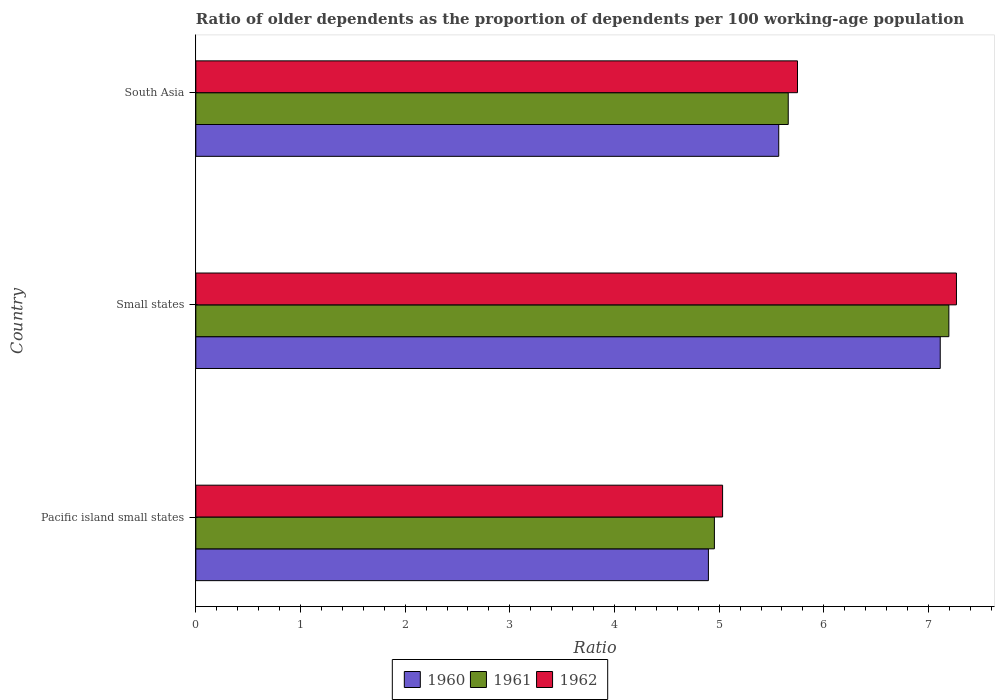Are the number of bars per tick equal to the number of legend labels?
Your answer should be very brief. Yes. Are the number of bars on each tick of the Y-axis equal?
Provide a succinct answer. Yes. How many bars are there on the 3rd tick from the top?
Offer a terse response. 3. How many bars are there on the 3rd tick from the bottom?
Your answer should be very brief. 3. What is the label of the 2nd group of bars from the top?
Offer a very short reply. Small states. In how many cases, is the number of bars for a given country not equal to the number of legend labels?
Offer a terse response. 0. What is the age dependency ratio(old) in 1960 in Pacific island small states?
Offer a terse response. 4.9. Across all countries, what is the maximum age dependency ratio(old) in 1961?
Keep it short and to the point. 7.19. Across all countries, what is the minimum age dependency ratio(old) in 1962?
Your answer should be compact. 5.03. In which country was the age dependency ratio(old) in 1960 maximum?
Keep it short and to the point. Small states. In which country was the age dependency ratio(old) in 1960 minimum?
Give a very brief answer. Pacific island small states. What is the total age dependency ratio(old) in 1960 in the graph?
Offer a very short reply. 17.58. What is the difference between the age dependency ratio(old) in 1962 in Pacific island small states and that in Small states?
Provide a succinct answer. -2.23. What is the difference between the age dependency ratio(old) in 1960 in Pacific island small states and the age dependency ratio(old) in 1962 in Small states?
Offer a terse response. -2.37. What is the average age dependency ratio(old) in 1962 per country?
Provide a succinct answer. 6.02. What is the difference between the age dependency ratio(old) in 1962 and age dependency ratio(old) in 1960 in Pacific island small states?
Your answer should be very brief. 0.14. What is the ratio of the age dependency ratio(old) in 1961 in Pacific island small states to that in South Asia?
Your response must be concise. 0.88. Is the difference between the age dependency ratio(old) in 1962 in Small states and South Asia greater than the difference between the age dependency ratio(old) in 1960 in Small states and South Asia?
Make the answer very short. No. What is the difference between the highest and the second highest age dependency ratio(old) in 1960?
Your answer should be compact. 1.54. What is the difference between the highest and the lowest age dependency ratio(old) in 1960?
Make the answer very short. 2.21. In how many countries, is the age dependency ratio(old) in 1960 greater than the average age dependency ratio(old) in 1960 taken over all countries?
Provide a succinct answer. 1. Is the sum of the age dependency ratio(old) in 1961 in Pacific island small states and Small states greater than the maximum age dependency ratio(old) in 1960 across all countries?
Your answer should be compact. Yes. What does the 2nd bar from the top in Pacific island small states represents?
Your answer should be compact. 1961. What does the 3rd bar from the bottom in Pacific island small states represents?
Your response must be concise. 1962. Is it the case that in every country, the sum of the age dependency ratio(old) in 1962 and age dependency ratio(old) in 1961 is greater than the age dependency ratio(old) in 1960?
Ensure brevity in your answer.  Yes. How many bars are there?
Provide a succinct answer. 9. What is the difference between two consecutive major ticks on the X-axis?
Offer a very short reply. 1. Does the graph contain any zero values?
Keep it short and to the point. No. Does the graph contain grids?
Make the answer very short. No. Where does the legend appear in the graph?
Provide a short and direct response. Bottom center. How many legend labels are there?
Ensure brevity in your answer.  3. What is the title of the graph?
Your response must be concise. Ratio of older dependents as the proportion of dependents per 100 working-age population. What is the label or title of the X-axis?
Your answer should be very brief. Ratio. What is the label or title of the Y-axis?
Provide a short and direct response. Country. What is the Ratio of 1960 in Pacific island small states?
Offer a terse response. 4.9. What is the Ratio in 1961 in Pacific island small states?
Your answer should be compact. 4.95. What is the Ratio in 1962 in Pacific island small states?
Make the answer very short. 5.03. What is the Ratio of 1960 in Small states?
Make the answer very short. 7.11. What is the Ratio in 1961 in Small states?
Provide a short and direct response. 7.19. What is the Ratio of 1962 in Small states?
Your answer should be very brief. 7.27. What is the Ratio of 1960 in South Asia?
Offer a terse response. 5.57. What is the Ratio of 1961 in South Asia?
Keep it short and to the point. 5.66. What is the Ratio of 1962 in South Asia?
Ensure brevity in your answer.  5.75. Across all countries, what is the maximum Ratio in 1960?
Ensure brevity in your answer.  7.11. Across all countries, what is the maximum Ratio of 1961?
Your response must be concise. 7.19. Across all countries, what is the maximum Ratio in 1962?
Keep it short and to the point. 7.27. Across all countries, what is the minimum Ratio of 1960?
Offer a terse response. 4.9. Across all countries, what is the minimum Ratio of 1961?
Your answer should be very brief. 4.95. Across all countries, what is the minimum Ratio of 1962?
Make the answer very short. 5.03. What is the total Ratio in 1960 in the graph?
Give a very brief answer. 17.58. What is the total Ratio in 1961 in the graph?
Your response must be concise. 17.81. What is the total Ratio of 1962 in the graph?
Make the answer very short. 18.05. What is the difference between the Ratio in 1960 in Pacific island small states and that in Small states?
Your answer should be compact. -2.21. What is the difference between the Ratio of 1961 in Pacific island small states and that in Small states?
Offer a terse response. -2.24. What is the difference between the Ratio in 1962 in Pacific island small states and that in Small states?
Offer a terse response. -2.23. What is the difference between the Ratio in 1960 in Pacific island small states and that in South Asia?
Provide a succinct answer. -0.67. What is the difference between the Ratio in 1961 in Pacific island small states and that in South Asia?
Offer a very short reply. -0.71. What is the difference between the Ratio in 1962 in Pacific island small states and that in South Asia?
Provide a short and direct response. -0.72. What is the difference between the Ratio in 1960 in Small states and that in South Asia?
Your response must be concise. 1.54. What is the difference between the Ratio of 1961 in Small states and that in South Asia?
Give a very brief answer. 1.53. What is the difference between the Ratio in 1962 in Small states and that in South Asia?
Offer a very short reply. 1.52. What is the difference between the Ratio of 1960 in Pacific island small states and the Ratio of 1961 in Small states?
Your answer should be compact. -2.3. What is the difference between the Ratio in 1960 in Pacific island small states and the Ratio in 1962 in Small states?
Give a very brief answer. -2.37. What is the difference between the Ratio in 1961 in Pacific island small states and the Ratio in 1962 in Small states?
Offer a very short reply. -2.31. What is the difference between the Ratio in 1960 in Pacific island small states and the Ratio in 1961 in South Asia?
Provide a short and direct response. -0.76. What is the difference between the Ratio in 1960 in Pacific island small states and the Ratio in 1962 in South Asia?
Offer a terse response. -0.85. What is the difference between the Ratio of 1961 in Pacific island small states and the Ratio of 1962 in South Asia?
Ensure brevity in your answer.  -0.79. What is the difference between the Ratio of 1960 in Small states and the Ratio of 1961 in South Asia?
Provide a succinct answer. 1.45. What is the difference between the Ratio in 1960 in Small states and the Ratio in 1962 in South Asia?
Provide a succinct answer. 1.36. What is the difference between the Ratio in 1961 in Small states and the Ratio in 1962 in South Asia?
Make the answer very short. 1.45. What is the average Ratio in 1960 per country?
Offer a terse response. 5.86. What is the average Ratio of 1961 per country?
Provide a succinct answer. 5.94. What is the average Ratio in 1962 per country?
Provide a short and direct response. 6.02. What is the difference between the Ratio in 1960 and Ratio in 1961 in Pacific island small states?
Give a very brief answer. -0.06. What is the difference between the Ratio of 1960 and Ratio of 1962 in Pacific island small states?
Provide a succinct answer. -0.14. What is the difference between the Ratio of 1961 and Ratio of 1962 in Pacific island small states?
Ensure brevity in your answer.  -0.08. What is the difference between the Ratio of 1960 and Ratio of 1961 in Small states?
Offer a very short reply. -0.08. What is the difference between the Ratio of 1960 and Ratio of 1962 in Small states?
Give a very brief answer. -0.15. What is the difference between the Ratio in 1961 and Ratio in 1962 in Small states?
Offer a terse response. -0.07. What is the difference between the Ratio in 1960 and Ratio in 1961 in South Asia?
Your answer should be compact. -0.09. What is the difference between the Ratio in 1960 and Ratio in 1962 in South Asia?
Keep it short and to the point. -0.18. What is the difference between the Ratio in 1961 and Ratio in 1962 in South Asia?
Your answer should be compact. -0.09. What is the ratio of the Ratio in 1960 in Pacific island small states to that in Small states?
Keep it short and to the point. 0.69. What is the ratio of the Ratio in 1961 in Pacific island small states to that in Small states?
Ensure brevity in your answer.  0.69. What is the ratio of the Ratio in 1962 in Pacific island small states to that in Small states?
Provide a succinct answer. 0.69. What is the ratio of the Ratio in 1960 in Pacific island small states to that in South Asia?
Give a very brief answer. 0.88. What is the ratio of the Ratio of 1961 in Pacific island small states to that in South Asia?
Your answer should be compact. 0.88. What is the ratio of the Ratio of 1962 in Pacific island small states to that in South Asia?
Provide a succinct answer. 0.88. What is the ratio of the Ratio in 1960 in Small states to that in South Asia?
Keep it short and to the point. 1.28. What is the ratio of the Ratio in 1961 in Small states to that in South Asia?
Offer a terse response. 1.27. What is the ratio of the Ratio of 1962 in Small states to that in South Asia?
Your answer should be compact. 1.26. What is the difference between the highest and the second highest Ratio in 1960?
Your answer should be compact. 1.54. What is the difference between the highest and the second highest Ratio in 1961?
Your answer should be compact. 1.53. What is the difference between the highest and the second highest Ratio in 1962?
Your response must be concise. 1.52. What is the difference between the highest and the lowest Ratio of 1960?
Your answer should be compact. 2.21. What is the difference between the highest and the lowest Ratio in 1961?
Keep it short and to the point. 2.24. What is the difference between the highest and the lowest Ratio in 1962?
Keep it short and to the point. 2.23. 